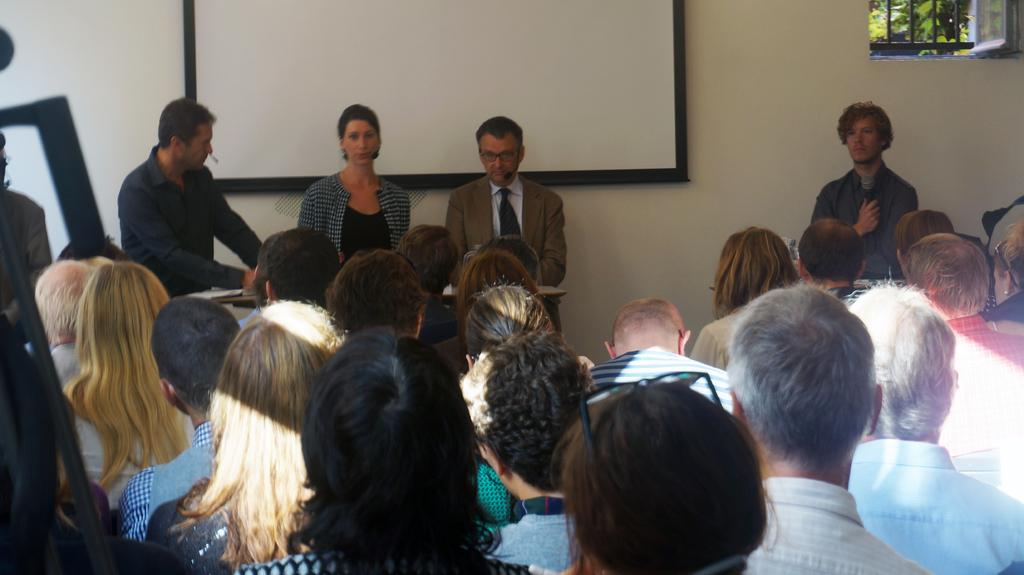What are the people in the image doing? Some people are sitting and some are standing in the center of the image. What can be seen on the wall in the background? There is a screen placed on the wall in the background. What is visible on the right side of the image? There is a window on the right side of the image. What type of development can be seen happening in the image? There is no development activity visible in the image. Is there a bed present in the image? There is no bed present in the image. 